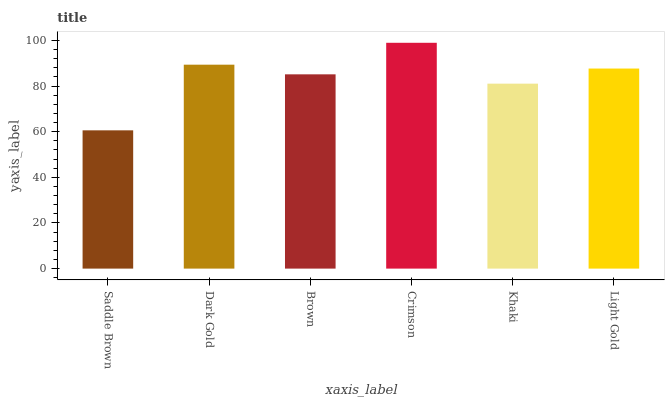Is Saddle Brown the minimum?
Answer yes or no. Yes. Is Crimson the maximum?
Answer yes or no. Yes. Is Dark Gold the minimum?
Answer yes or no. No. Is Dark Gold the maximum?
Answer yes or no. No. Is Dark Gold greater than Saddle Brown?
Answer yes or no. Yes. Is Saddle Brown less than Dark Gold?
Answer yes or no. Yes. Is Saddle Brown greater than Dark Gold?
Answer yes or no. No. Is Dark Gold less than Saddle Brown?
Answer yes or no. No. Is Light Gold the high median?
Answer yes or no. Yes. Is Brown the low median?
Answer yes or no. Yes. Is Brown the high median?
Answer yes or no. No. Is Khaki the low median?
Answer yes or no. No. 